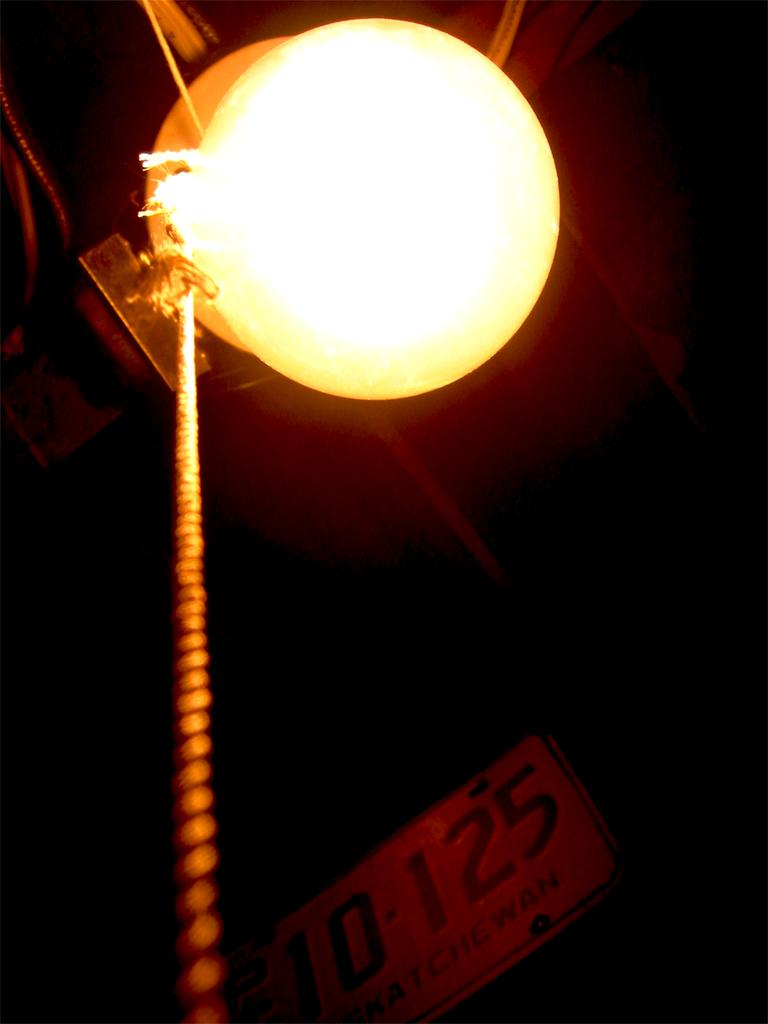What is located in the foreground of the image? There is a rope in the foreground of the image. What is attached to the top of the rope? There is a light at the top of the rope in the foreground. What can be seen in the background of the image? The background of the image is dark, and there is a board in the background. How many visitors can be seen interacting with the rope and light in the image? There is no mention of visitors in the image, and therefore no such interaction can be observed. What type of destruction is depicted in the image? There is no destruction depicted in the image; it features a rope, a light, a dark background, and a board. 